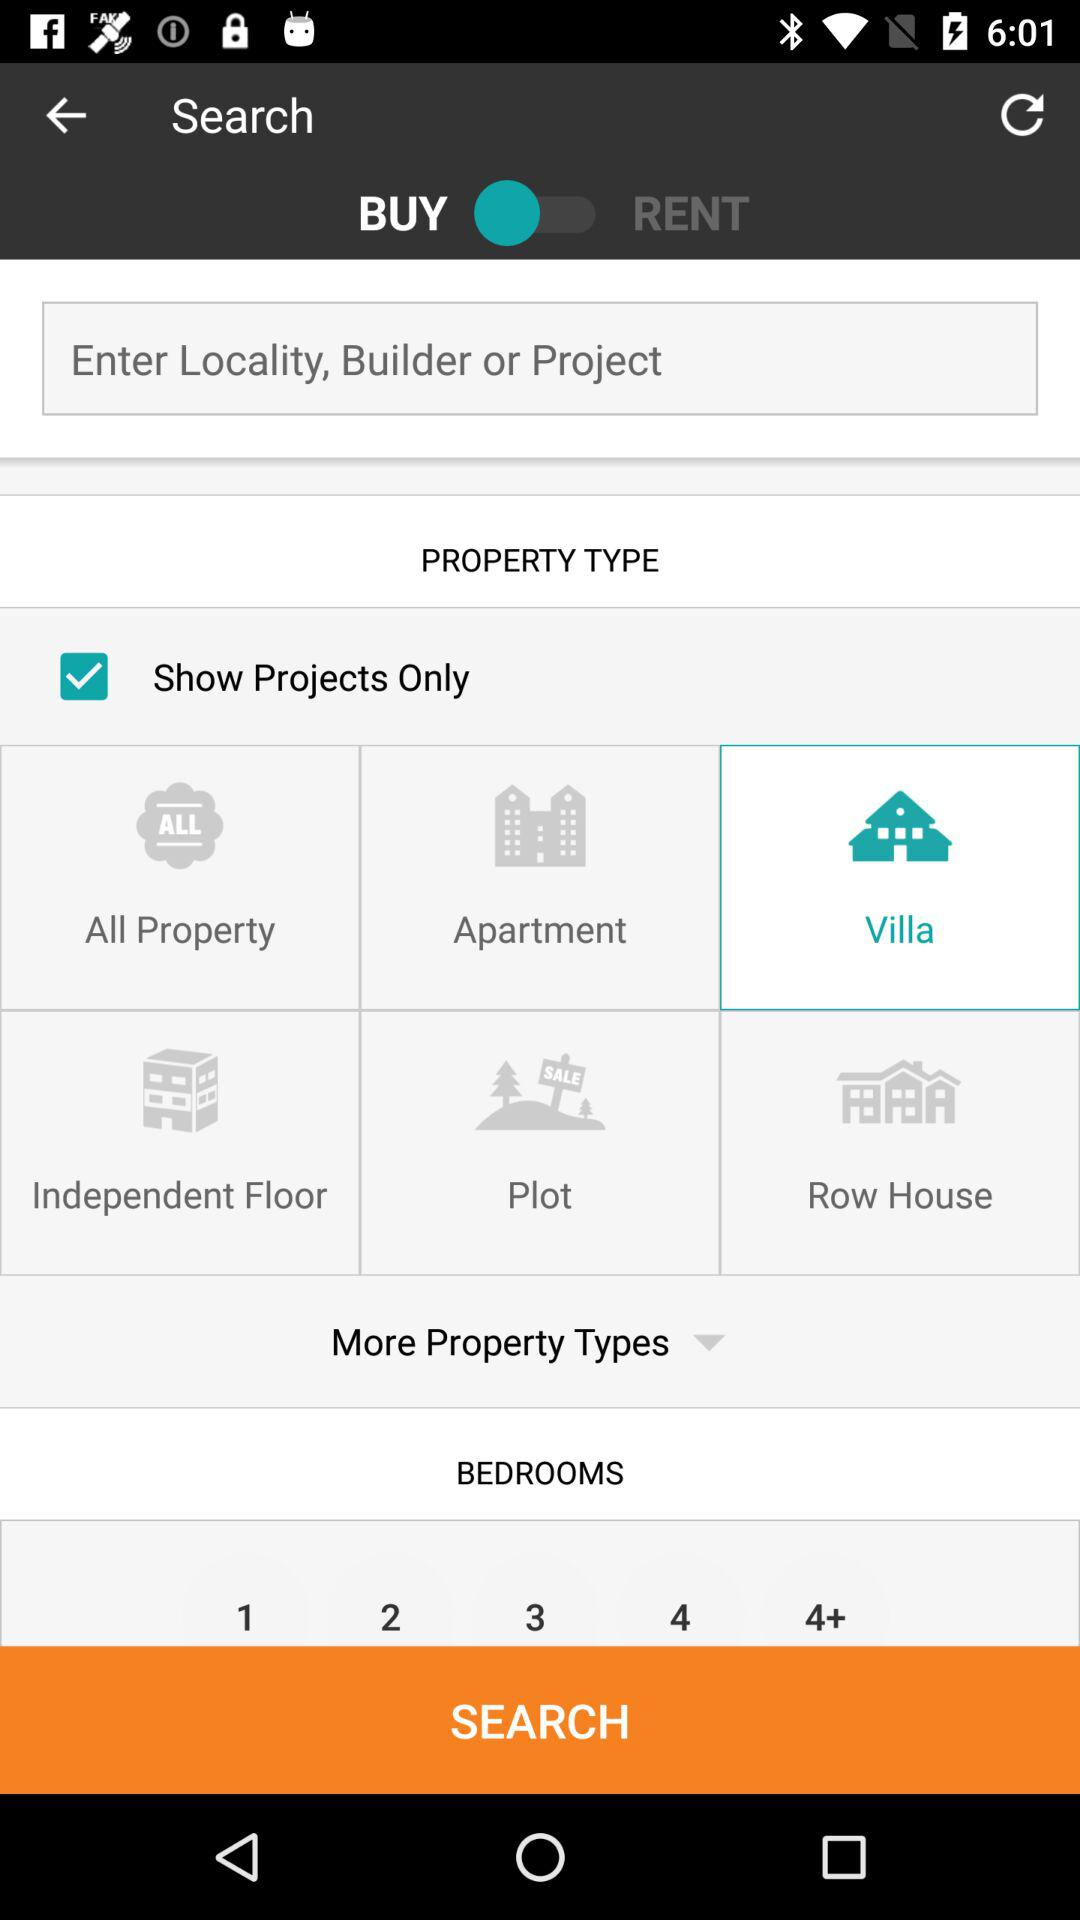How many bedrooms are available?
Answer the question using a single word or phrase. 1, 2, 3, 4, 4+ 